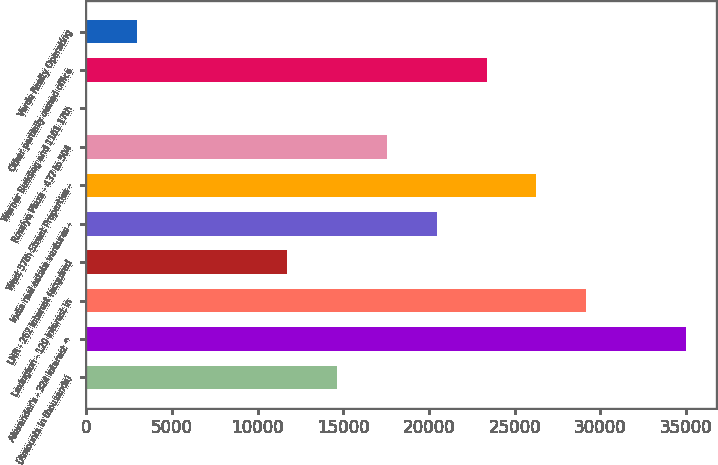Convert chart to OTSL. <chart><loc_0><loc_0><loc_500><loc_500><bar_chart><fcel>(Amounts in thousands)<fcel>Alexander's - 324 interest ^<fcel>Lexington - 120 interest in<fcel>LNR - 262 interest (acquired<fcel>India real estate ventures -<fcel>West 57th Street Properties -<fcel>Rosslyn Plaza - 437 to 504<fcel>Warner Building and 1101 17th<fcel>Other partially owned office<fcel>Verde Realty Operating<nl><fcel>14628<fcel>35006.4<fcel>29184<fcel>11716.8<fcel>20450.4<fcel>26272.8<fcel>17539.2<fcel>72<fcel>23361.6<fcel>2983.2<nl></chart> 